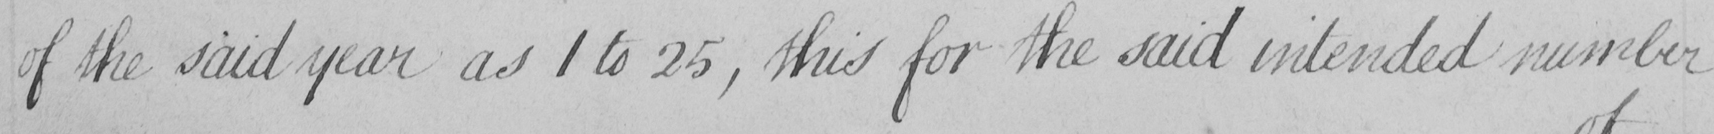Can you tell me what this handwritten text says? of the said year as 1 to 25 , this for the said intended number 